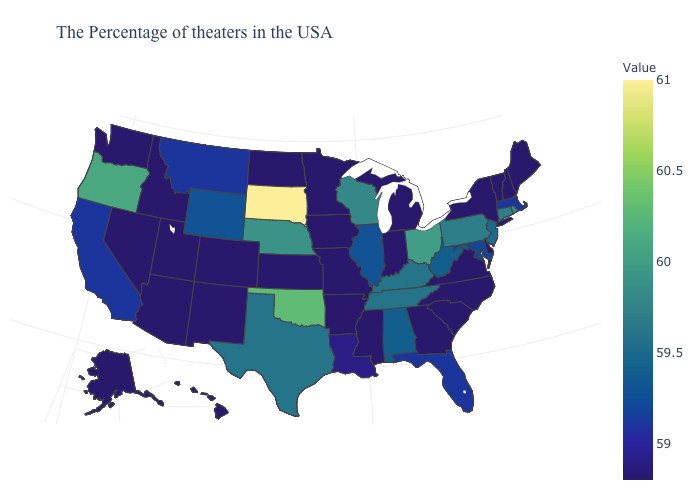Among the states that border Idaho , does Utah have the highest value?
Write a very short answer. No. Does Connecticut have a higher value than Oklahoma?
Keep it brief. No. Does Rhode Island have the highest value in the Northeast?
Write a very short answer. Yes. 